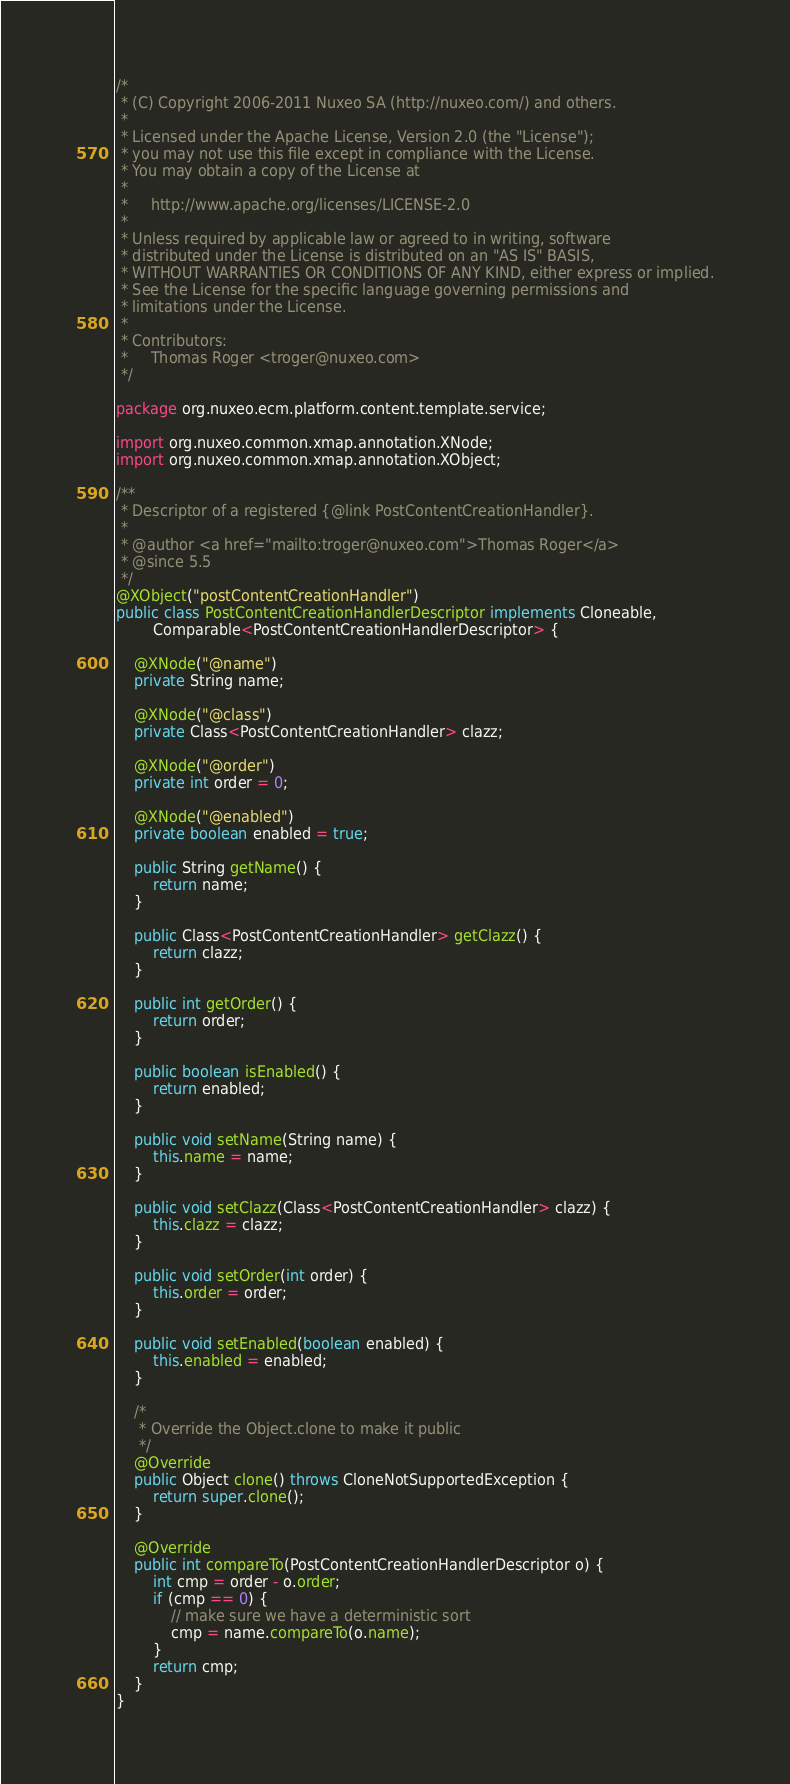<code> <loc_0><loc_0><loc_500><loc_500><_Java_>/*
 * (C) Copyright 2006-2011 Nuxeo SA (http://nuxeo.com/) and others.
 *
 * Licensed under the Apache License, Version 2.0 (the "License");
 * you may not use this file except in compliance with the License.
 * You may obtain a copy of the License at
 *
 *     http://www.apache.org/licenses/LICENSE-2.0
 *
 * Unless required by applicable law or agreed to in writing, software
 * distributed under the License is distributed on an "AS IS" BASIS,
 * WITHOUT WARRANTIES OR CONDITIONS OF ANY KIND, either express or implied.
 * See the License for the specific language governing permissions and
 * limitations under the License.
 *
 * Contributors:
 *     Thomas Roger <troger@nuxeo.com>
 */

package org.nuxeo.ecm.platform.content.template.service;

import org.nuxeo.common.xmap.annotation.XNode;
import org.nuxeo.common.xmap.annotation.XObject;

/**
 * Descriptor of a registered {@link PostContentCreationHandler}.
 *
 * @author <a href="mailto:troger@nuxeo.com">Thomas Roger</a>
 * @since 5.5
 */
@XObject("postContentCreationHandler")
public class PostContentCreationHandlerDescriptor implements Cloneable,
        Comparable<PostContentCreationHandlerDescriptor> {

    @XNode("@name")
    private String name;

    @XNode("@class")
    private Class<PostContentCreationHandler> clazz;

    @XNode("@order")
    private int order = 0;

    @XNode("@enabled")
    private boolean enabled = true;

    public String getName() {
        return name;
    }

    public Class<PostContentCreationHandler> getClazz() {
        return clazz;
    }

    public int getOrder() {
        return order;
    }

    public boolean isEnabled() {
        return enabled;
    }

    public void setName(String name) {
        this.name = name;
    }

    public void setClazz(Class<PostContentCreationHandler> clazz) {
        this.clazz = clazz;
    }

    public void setOrder(int order) {
        this.order = order;
    }

    public void setEnabled(boolean enabled) {
        this.enabled = enabled;
    }

    /*
     * Override the Object.clone to make it public
     */
    @Override
    public Object clone() throws CloneNotSupportedException {
        return super.clone();
    }

    @Override
    public int compareTo(PostContentCreationHandlerDescriptor o) {
        int cmp = order - o.order;
        if (cmp == 0) {
            // make sure we have a deterministic sort
            cmp = name.compareTo(o.name);
        }
        return cmp;
    }
}
</code> 